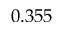<formula> <loc_0><loc_0><loc_500><loc_500>0 . 3 5 5</formula> 